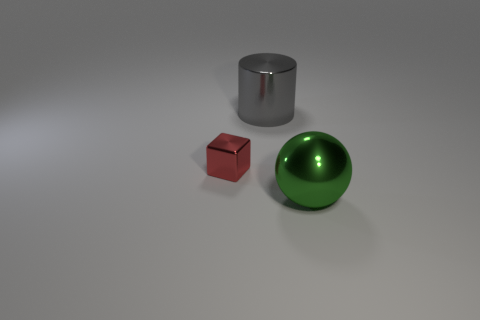Add 2 large cyan matte cylinders. How many objects exist? 5 Subtract all blocks. How many objects are left? 2 Subtract all cyan cylinders. Subtract all cyan balls. How many cylinders are left? 1 Subtract all yellow cylinders. How many brown blocks are left? 0 Subtract all purple things. Subtract all big cylinders. How many objects are left? 2 Add 2 tiny metallic things. How many tiny metallic things are left? 3 Add 2 yellow things. How many yellow things exist? 2 Subtract 0 cyan balls. How many objects are left? 3 